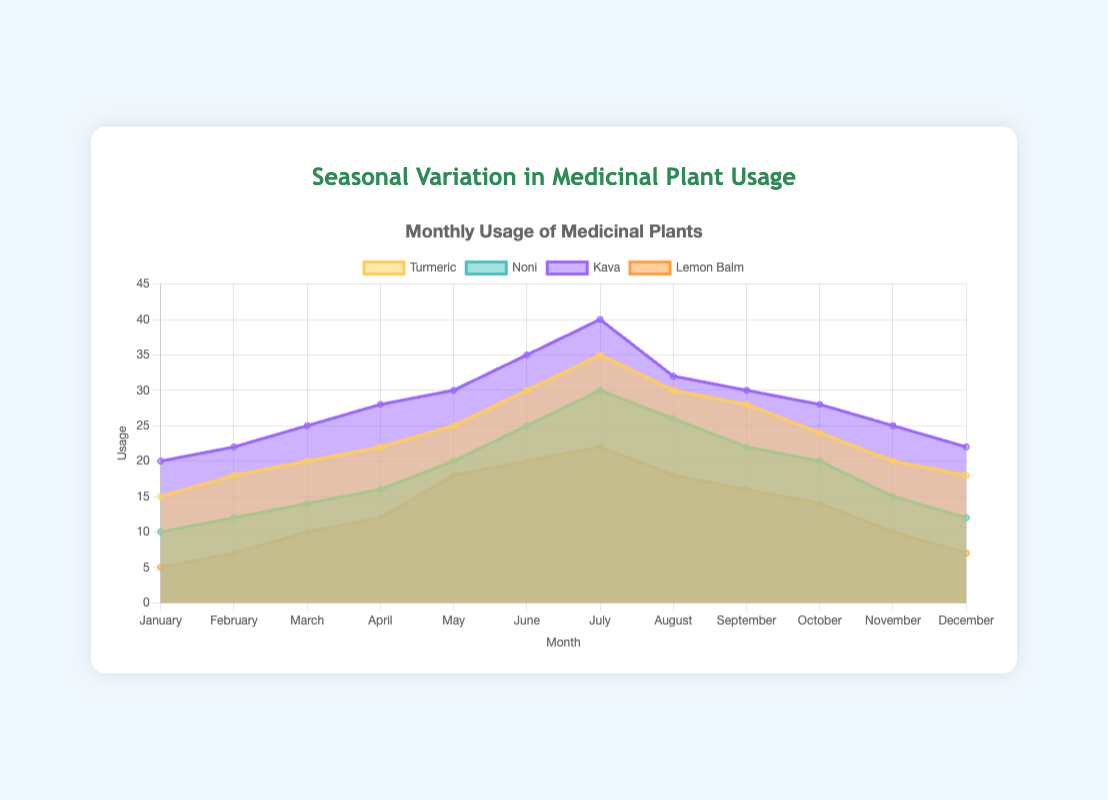What is the title of the chart? The title of the chart is written at the top and provides an overview of the purpose of the figure.
Answer: Seasonal Variation in Medicinal Plant Usage How many medicinal plants are tracked in this chart? Count the number of distinct labels in the dataset. The labels correspond to each unique medicinal plant.
Answer: 4 Which medicinal plant had the highest usage in July? Look at the data values for July and compare the figures for Turmeric, Noni, Kava, and Lemon Balm. The highest value indicates the highest usage.
Answer: Kava What is the lowest recorded usage of Lemon Balm and in which month did it occur? Find the minimum value in the data for Lemon Balm and identify the corresponding month.
Answer: January with 5 uses Compare the usage of Turmeric in January and July. What is the difference? Subtract the value of Turmeric usage in January from the value in July.
Answer: 20 (35 - 15) In which month did Noni usage peak, and what was the value? Identify the month with the highest value in the Noni dataset.
Answer: July with 30 uses How does the usage of medicinal plants change across seasons? Observe the trend lines for all plants from January to December to identify any patterns or fluctuations. Based on the data, there are increasing trends in the initial months and decreasing trends towards the end of the year.
Answer: Usage increases until mid-year and decreases towards the year-end What is the average usage of Lemon Balm throughout the year? Add up all the Lemon Balm usage values and divide by the total number of months (12).
Answer: 12 (5+7+10+12+18+20+22+18+16+14+10+7)/12 Which month shows the most balanced usage across all four plants? Identify the month where the usage values of the four plants are closest to each other. This can be done by computing the range (difference between the highest and lowest values) for each month and identifying the smallest range.
Answer: October (Turmeric: 24, Noni: 20, Kava: 28, Lemon Balm: 14, Range: 14) What was the total usage of all four plants in June? Add up the usage values for each of the four plants in June.
Answer: 110 (30 + 25 + 35 + 20) 